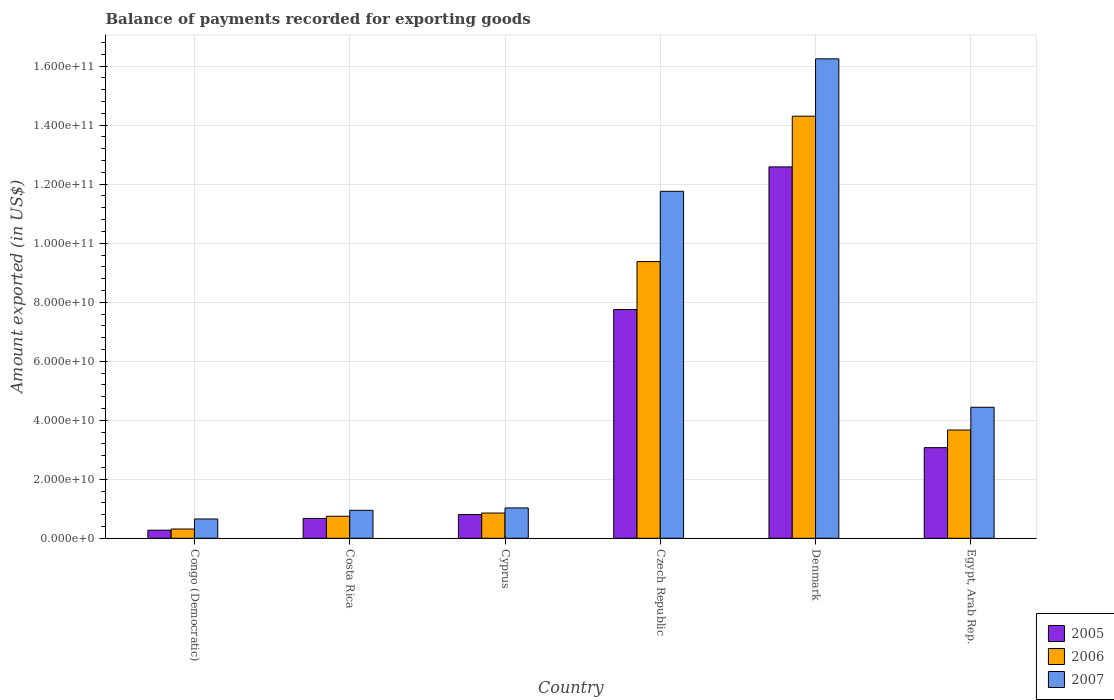How many different coloured bars are there?
Provide a short and direct response. 3. How many groups of bars are there?
Your answer should be compact. 6. Are the number of bars on each tick of the X-axis equal?
Offer a terse response. Yes. How many bars are there on the 6th tick from the left?
Ensure brevity in your answer.  3. In how many cases, is the number of bars for a given country not equal to the number of legend labels?
Your answer should be very brief. 0. What is the amount exported in 2007 in Egypt, Arab Rep.?
Provide a short and direct response. 4.44e+1. Across all countries, what is the maximum amount exported in 2005?
Your response must be concise. 1.26e+11. Across all countries, what is the minimum amount exported in 2007?
Your answer should be very brief. 6.54e+09. In which country was the amount exported in 2006 minimum?
Provide a succinct answer. Congo (Democratic). What is the total amount exported in 2005 in the graph?
Keep it short and to the point. 2.52e+11. What is the difference between the amount exported in 2007 in Denmark and that in Egypt, Arab Rep.?
Give a very brief answer. 1.18e+11. What is the difference between the amount exported in 2006 in Congo (Democratic) and the amount exported in 2007 in Costa Rica?
Offer a terse response. -6.34e+09. What is the average amount exported in 2005 per country?
Provide a succinct answer. 4.19e+1. What is the difference between the amount exported of/in 2007 and amount exported of/in 2005 in Costa Rica?
Provide a short and direct response. 2.75e+09. In how many countries, is the amount exported in 2006 greater than 136000000000 US$?
Your answer should be very brief. 1. What is the ratio of the amount exported in 2007 in Congo (Democratic) to that in Egypt, Arab Rep.?
Keep it short and to the point. 0.15. Is the difference between the amount exported in 2007 in Congo (Democratic) and Egypt, Arab Rep. greater than the difference between the amount exported in 2005 in Congo (Democratic) and Egypt, Arab Rep.?
Ensure brevity in your answer.  No. What is the difference between the highest and the second highest amount exported in 2007?
Your answer should be very brief. 4.49e+1. What is the difference between the highest and the lowest amount exported in 2006?
Your answer should be very brief. 1.40e+11. Is it the case that in every country, the sum of the amount exported in 2005 and amount exported in 2007 is greater than the amount exported in 2006?
Your answer should be very brief. Yes. How many bars are there?
Give a very brief answer. 18. Are all the bars in the graph horizontal?
Make the answer very short. No. How many countries are there in the graph?
Provide a succinct answer. 6. What is the difference between two consecutive major ticks on the Y-axis?
Offer a terse response. 2.00e+1. Are the values on the major ticks of Y-axis written in scientific E-notation?
Your response must be concise. Yes. Does the graph contain grids?
Provide a short and direct response. Yes. How many legend labels are there?
Provide a succinct answer. 3. What is the title of the graph?
Offer a terse response. Balance of payments recorded for exporting goods. What is the label or title of the Y-axis?
Offer a very short reply. Amount exported (in US$). What is the Amount exported (in US$) in 2005 in Congo (Democratic)?
Your answer should be very brief. 2.75e+09. What is the Amount exported (in US$) in 2006 in Congo (Democratic)?
Your answer should be very brief. 3.14e+09. What is the Amount exported (in US$) of 2007 in Congo (Democratic)?
Keep it short and to the point. 6.54e+09. What is the Amount exported (in US$) of 2005 in Costa Rica?
Give a very brief answer. 6.73e+09. What is the Amount exported (in US$) in 2006 in Costa Rica?
Keep it short and to the point. 7.47e+09. What is the Amount exported (in US$) of 2007 in Costa Rica?
Ensure brevity in your answer.  9.48e+09. What is the Amount exported (in US$) in 2005 in Cyprus?
Provide a succinct answer. 8.05e+09. What is the Amount exported (in US$) of 2006 in Cyprus?
Keep it short and to the point. 8.55e+09. What is the Amount exported (in US$) of 2007 in Cyprus?
Provide a short and direct response. 1.03e+1. What is the Amount exported (in US$) in 2005 in Czech Republic?
Keep it short and to the point. 7.75e+1. What is the Amount exported (in US$) in 2006 in Czech Republic?
Keep it short and to the point. 9.38e+1. What is the Amount exported (in US$) in 2007 in Czech Republic?
Your answer should be compact. 1.18e+11. What is the Amount exported (in US$) in 2005 in Denmark?
Keep it short and to the point. 1.26e+11. What is the Amount exported (in US$) in 2006 in Denmark?
Your answer should be compact. 1.43e+11. What is the Amount exported (in US$) in 2007 in Denmark?
Ensure brevity in your answer.  1.62e+11. What is the Amount exported (in US$) in 2005 in Egypt, Arab Rep.?
Provide a short and direct response. 3.07e+1. What is the Amount exported (in US$) in 2006 in Egypt, Arab Rep.?
Make the answer very short. 3.67e+1. What is the Amount exported (in US$) of 2007 in Egypt, Arab Rep.?
Offer a very short reply. 4.44e+1. Across all countries, what is the maximum Amount exported (in US$) in 2005?
Your answer should be compact. 1.26e+11. Across all countries, what is the maximum Amount exported (in US$) of 2006?
Provide a succinct answer. 1.43e+11. Across all countries, what is the maximum Amount exported (in US$) in 2007?
Offer a terse response. 1.62e+11. Across all countries, what is the minimum Amount exported (in US$) of 2005?
Give a very brief answer. 2.75e+09. Across all countries, what is the minimum Amount exported (in US$) in 2006?
Make the answer very short. 3.14e+09. Across all countries, what is the minimum Amount exported (in US$) in 2007?
Provide a short and direct response. 6.54e+09. What is the total Amount exported (in US$) in 2005 in the graph?
Your response must be concise. 2.52e+11. What is the total Amount exported (in US$) of 2006 in the graph?
Ensure brevity in your answer.  2.93e+11. What is the total Amount exported (in US$) of 2007 in the graph?
Your answer should be compact. 3.51e+11. What is the difference between the Amount exported (in US$) of 2005 in Congo (Democratic) and that in Costa Rica?
Offer a terse response. -3.98e+09. What is the difference between the Amount exported (in US$) of 2006 in Congo (Democratic) and that in Costa Rica?
Your response must be concise. -4.33e+09. What is the difference between the Amount exported (in US$) in 2007 in Congo (Democratic) and that in Costa Rica?
Keep it short and to the point. -2.94e+09. What is the difference between the Amount exported (in US$) in 2005 in Congo (Democratic) and that in Cyprus?
Provide a succinct answer. -5.30e+09. What is the difference between the Amount exported (in US$) of 2006 in Congo (Democratic) and that in Cyprus?
Offer a very short reply. -5.42e+09. What is the difference between the Amount exported (in US$) in 2007 in Congo (Democratic) and that in Cyprus?
Offer a very short reply. -3.75e+09. What is the difference between the Amount exported (in US$) of 2005 in Congo (Democratic) and that in Czech Republic?
Give a very brief answer. -7.48e+1. What is the difference between the Amount exported (in US$) in 2006 in Congo (Democratic) and that in Czech Republic?
Your answer should be very brief. -9.06e+1. What is the difference between the Amount exported (in US$) of 2007 in Congo (Democratic) and that in Czech Republic?
Offer a very short reply. -1.11e+11. What is the difference between the Amount exported (in US$) of 2005 in Congo (Democratic) and that in Denmark?
Your response must be concise. -1.23e+11. What is the difference between the Amount exported (in US$) in 2006 in Congo (Democratic) and that in Denmark?
Ensure brevity in your answer.  -1.40e+11. What is the difference between the Amount exported (in US$) in 2007 in Congo (Democratic) and that in Denmark?
Keep it short and to the point. -1.56e+11. What is the difference between the Amount exported (in US$) in 2005 in Congo (Democratic) and that in Egypt, Arab Rep.?
Your response must be concise. -2.80e+1. What is the difference between the Amount exported (in US$) in 2006 in Congo (Democratic) and that in Egypt, Arab Rep.?
Your response must be concise. -3.35e+1. What is the difference between the Amount exported (in US$) in 2007 in Congo (Democratic) and that in Egypt, Arab Rep.?
Keep it short and to the point. -3.79e+1. What is the difference between the Amount exported (in US$) in 2005 in Costa Rica and that in Cyprus?
Your answer should be very brief. -1.32e+09. What is the difference between the Amount exported (in US$) in 2006 in Costa Rica and that in Cyprus?
Ensure brevity in your answer.  -1.08e+09. What is the difference between the Amount exported (in US$) of 2007 in Costa Rica and that in Cyprus?
Offer a terse response. -8.10e+08. What is the difference between the Amount exported (in US$) in 2005 in Costa Rica and that in Czech Republic?
Your answer should be compact. -7.08e+1. What is the difference between the Amount exported (in US$) of 2006 in Costa Rica and that in Czech Republic?
Your answer should be very brief. -8.63e+1. What is the difference between the Amount exported (in US$) of 2007 in Costa Rica and that in Czech Republic?
Your answer should be compact. -1.08e+11. What is the difference between the Amount exported (in US$) in 2005 in Costa Rica and that in Denmark?
Your answer should be very brief. -1.19e+11. What is the difference between the Amount exported (in US$) in 2006 in Costa Rica and that in Denmark?
Provide a succinct answer. -1.36e+11. What is the difference between the Amount exported (in US$) in 2007 in Costa Rica and that in Denmark?
Your answer should be compact. -1.53e+11. What is the difference between the Amount exported (in US$) in 2005 in Costa Rica and that in Egypt, Arab Rep.?
Your answer should be very brief. -2.40e+1. What is the difference between the Amount exported (in US$) in 2006 in Costa Rica and that in Egypt, Arab Rep.?
Give a very brief answer. -2.92e+1. What is the difference between the Amount exported (in US$) in 2007 in Costa Rica and that in Egypt, Arab Rep.?
Provide a short and direct response. -3.49e+1. What is the difference between the Amount exported (in US$) in 2005 in Cyprus and that in Czech Republic?
Offer a very short reply. -6.95e+1. What is the difference between the Amount exported (in US$) in 2006 in Cyprus and that in Czech Republic?
Offer a very short reply. -8.52e+1. What is the difference between the Amount exported (in US$) in 2007 in Cyprus and that in Czech Republic?
Your answer should be very brief. -1.07e+11. What is the difference between the Amount exported (in US$) in 2005 in Cyprus and that in Denmark?
Your answer should be compact. -1.18e+11. What is the difference between the Amount exported (in US$) of 2006 in Cyprus and that in Denmark?
Provide a succinct answer. -1.34e+11. What is the difference between the Amount exported (in US$) of 2007 in Cyprus and that in Denmark?
Make the answer very short. -1.52e+11. What is the difference between the Amount exported (in US$) of 2005 in Cyprus and that in Egypt, Arab Rep.?
Your response must be concise. -2.27e+1. What is the difference between the Amount exported (in US$) in 2006 in Cyprus and that in Egypt, Arab Rep.?
Make the answer very short. -2.81e+1. What is the difference between the Amount exported (in US$) in 2007 in Cyprus and that in Egypt, Arab Rep.?
Your answer should be very brief. -3.41e+1. What is the difference between the Amount exported (in US$) of 2005 in Czech Republic and that in Denmark?
Your answer should be compact. -4.83e+1. What is the difference between the Amount exported (in US$) of 2006 in Czech Republic and that in Denmark?
Provide a short and direct response. -4.93e+1. What is the difference between the Amount exported (in US$) of 2007 in Czech Republic and that in Denmark?
Provide a succinct answer. -4.49e+1. What is the difference between the Amount exported (in US$) of 2005 in Czech Republic and that in Egypt, Arab Rep.?
Keep it short and to the point. 4.68e+1. What is the difference between the Amount exported (in US$) in 2006 in Czech Republic and that in Egypt, Arab Rep.?
Your answer should be very brief. 5.71e+1. What is the difference between the Amount exported (in US$) in 2007 in Czech Republic and that in Egypt, Arab Rep.?
Keep it short and to the point. 7.32e+1. What is the difference between the Amount exported (in US$) in 2005 in Denmark and that in Egypt, Arab Rep.?
Ensure brevity in your answer.  9.51e+1. What is the difference between the Amount exported (in US$) of 2006 in Denmark and that in Egypt, Arab Rep.?
Ensure brevity in your answer.  1.06e+11. What is the difference between the Amount exported (in US$) of 2007 in Denmark and that in Egypt, Arab Rep.?
Ensure brevity in your answer.  1.18e+11. What is the difference between the Amount exported (in US$) in 2005 in Congo (Democratic) and the Amount exported (in US$) in 2006 in Costa Rica?
Offer a terse response. -4.72e+09. What is the difference between the Amount exported (in US$) of 2005 in Congo (Democratic) and the Amount exported (in US$) of 2007 in Costa Rica?
Your response must be concise. -6.73e+09. What is the difference between the Amount exported (in US$) in 2006 in Congo (Democratic) and the Amount exported (in US$) in 2007 in Costa Rica?
Keep it short and to the point. -6.34e+09. What is the difference between the Amount exported (in US$) of 2005 in Congo (Democratic) and the Amount exported (in US$) of 2006 in Cyprus?
Offer a terse response. -5.81e+09. What is the difference between the Amount exported (in US$) of 2005 in Congo (Democratic) and the Amount exported (in US$) of 2007 in Cyprus?
Keep it short and to the point. -7.54e+09. What is the difference between the Amount exported (in US$) of 2006 in Congo (Democratic) and the Amount exported (in US$) of 2007 in Cyprus?
Give a very brief answer. -7.15e+09. What is the difference between the Amount exported (in US$) in 2005 in Congo (Democratic) and the Amount exported (in US$) in 2006 in Czech Republic?
Keep it short and to the point. -9.10e+1. What is the difference between the Amount exported (in US$) of 2005 in Congo (Democratic) and the Amount exported (in US$) of 2007 in Czech Republic?
Offer a very short reply. -1.15e+11. What is the difference between the Amount exported (in US$) of 2006 in Congo (Democratic) and the Amount exported (in US$) of 2007 in Czech Republic?
Keep it short and to the point. -1.14e+11. What is the difference between the Amount exported (in US$) of 2005 in Congo (Democratic) and the Amount exported (in US$) of 2006 in Denmark?
Offer a very short reply. -1.40e+11. What is the difference between the Amount exported (in US$) of 2005 in Congo (Democratic) and the Amount exported (in US$) of 2007 in Denmark?
Give a very brief answer. -1.60e+11. What is the difference between the Amount exported (in US$) in 2006 in Congo (Democratic) and the Amount exported (in US$) in 2007 in Denmark?
Give a very brief answer. -1.59e+11. What is the difference between the Amount exported (in US$) of 2005 in Congo (Democratic) and the Amount exported (in US$) of 2006 in Egypt, Arab Rep.?
Provide a succinct answer. -3.39e+1. What is the difference between the Amount exported (in US$) of 2005 in Congo (Democratic) and the Amount exported (in US$) of 2007 in Egypt, Arab Rep.?
Provide a succinct answer. -4.17e+1. What is the difference between the Amount exported (in US$) of 2006 in Congo (Democratic) and the Amount exported (in US$) of 2007 in Egypt, Arab Rep.?
Offer a terse response. -4.13e+1. What is the difference between the Amount exported (in US$) of 2005 in Costa Rica and the Amount exported (in US$) of 2006 in Cyprus?
Provide a short and direct response. -1.82e+09. What is the difference between the Amount exported (in US$) in 2005 in Costa Rica and the Amount exported (in US$) in 2007 in Cyprus?
Provide a succinct answer. -3.56e+09. What is the difference between the Amount exported (in US$) of 2006 in Costa Rica and the Amount exported (in US$) of 2007 in Cyprus?
Give a very brief answer. -2.82e+09. What is the difference between the Amount exported (in US$) in 2005 in Costa Rica and the Amount exported (in US$) in 2006 in Czech Republic?
Ensure brevity in your answer.  -8.70e+1. What is the difference between the Amount exported (in US$) of 2005 in Costa Rica and the Amount exported (in US$) of 2007 in Czech Republic?
Your response must be concise. -1.11e+11. What is the difference between the Amount exported (in US$) of 2006 in Costa Rica and the Amount exported (in US$) of 2007 in Czech Republic?
Give a very brief answer. -1.10e+11. What is the difference between the Amount exported (in US$) in 2005 in Costa Rica and the Amount exported (in US$) in 2006 in Denmark?
Your answer should be compact. -1.36e+11. What is the difference between the Amount exported (in US$) in 2005 in Costa Rica and the Amount exported (in US$) in 2007 in Denmark?
Offer a very short reply. -1.56e+11. What is the difference between the Amount exported (in US$) in 2006 in Costa Rica and the Amount exported (in US$) in 2007 in Denmark?
Your answer should be very brief. -1.55e+11. What is the difference between the Amount exported (in US$) of 2005 in Costa Rica and the Amount exported (in US$) of 2006 in Egypt, Arab Rep.?
Offer a terse response. -3.00e+1. What is the difference between the Amount exported (in US$) in 2005 in Costa Rica and the Amount exported (in US$) in 2007 in Egypt, Arab Rep.?
Provide a succinct answer. -3.77e+1. What is the difference between the Amount exported (in US$) in 2006 in Costa Rica and the Amount exported (in US$) in 2007 in Egypt, Arab Rep.?
Provide a short and direct response. -3.69e+1. What is the difference between the Amount exported (in US$) of 2005 in Cyprus and the Amount exported (in US$) of 2006 in Czech Republic?
Provide a succinct answer. -8.57e+1. What is the difference between the Amount exported (in US$) of 2005 in Cyprus and the Amount exported (in US$) of 2007 in Czech Republic?
Your answer should be very brief. -1.10e+11. What is the difference between the Amount exported (in US$) in 2006 in Cyprus and the Amount exported (in US$) in 2007 in Czech Republic?
Give a very brief answer. -1.09e+11. What is the difference between the Amount exported (in US$) of 2005 in Cyprus and the Amount exported (in US$) of 2006 in Denmark?
Offer a terse response. -1.35e+11. What is the difference between the Amount exported (in US$) of 2005 in Cyprus and the Amount exported (in US$) of 2007 in Denmark?
Give a very brief answer. -1.54e+11. What is the difference between the Amount exported (in US$) in 2006 in Cyprus and the Amount exported (in US$) in 2007 in Denmark?
Offer a very short reply. -1.54e+11. What is the difference between the Amount exported (in US$) of 2005 in Cyprus and the Amount exported (in US$) of 2006 in Egypt, Arab Rep.?
Your response must be concise. -2.86e+1. What is the difference between the Amount exported (in US$) in 2005 in Cyprus and the Amount exported (in US$) in 2007 in Egypt, Arab Rep.?
Ensure brevity in your answer.  -3.64e+1. What is the difference between the Amount exported (in US$) of 2006 in Cyprus and the Amount exported (in US$) of 2007 in Egypt, Arab Rep.?
Make the answer very short. -3.58e+1. What is the difference between the Amount exported (in US$) of 2005 in Czech Republic and the Amount exported (in US$) of 2006 in Denmark?
Ensure brevity in your answer.  -6.55e+1. What is the difference between the Amount exported (in US$) in 2005 in Czech Republic and the Amount exported (in US$) in 2007 in Denmark?
Keep it short and to the point. -8.50e+1. What is the difference between the Amount exported (in US$) of 2006 in Czech Republic and the Amount exported (in US$) of 2007 in Denmark?
Your answer should be compact. -6.87e+1. What is the difference between the Amount exported (in US$) of 2005 in Czech Republic and the Amount exported (in US$) of 2006 in Egypt, Arab Rep.?
Your response must be concise. 4.08e+1. What is the difference between the Amount exported (in US$) in 2005 in Czech Republic and the Amount exported (in US$) in 2007 in Egypt, Arab Rep.?
Give a very brief answer. 3.31e+1. What is the difference between the Amount exported (in US$) of 2006 in Czech Republic and the Amount exported (in US$) of 2007 in Egypt, Arab Rep.?
Provide a short and direct response. 4.94e+1. What is the difference between the Amount exported (in US$) in 2005 in Denmark and the Amount exported (in US$) in 2006 in Egypt, Arab Rep.?
Make the answer very short. 8.92e+1. What is the difference between the Amount exported (in US$) in 2005 in Denmark and the Amount exported (in US$) in 2007 in Egypt, Arab Rep.?
Your response must be concise. 8.15e+1. What is the difference between the Amount exported (in US$) of 2006 in Denmark and the Amount exported (in US$) of 2007 in Egypt, Arab Rep.?
Offer a very short reply. 9.86e+1. What is the average Amount exported (in US$) in 2005 per country?
Ensure brevity in your answer.  4.19e+1. What is the average Amount exported (in US$) of 2006 per country?
Provide a short and direct response. 4.88e+1. What is the average Amount exported (in US$) in 2007 per country?
Your answer should be compact. 5.85e+1. What is the difference between the Amount exported (in US$) of 2005 and Amount exported (in US$) of 2006 in Congo (Democratic)?
Make the answer very short. -3.92e+08. What is the difference between the Amount exported (in US$) in 2005 and Amount exported (in US$) in 2007 in Congo (Democratic)?
Provide a short and direct response. -3.79e+09. What is the difference between the Amount exported (in US$) of 2006 and Amount exported (in US$) of 2007 in Congo (Democratic)?
Ensure brevity in your answer.  -3.40e+09. What is the difference between the Amount exported (in US$) in 2005 and Amount exported (in US$) in 2006 in Costa Rica?
Offer a very short reply. -7.41e+08. What is the difference between the Amount exported (in US$) in 2005 and Amount exported (in US$) in 2007 in Costa Rica?
Provide a short and direct response. -2.75e+09. What is the difference between the Amount exported (in US$) of 2006 and Amount exported (in US$) of 2007 in Costa Rica?
Offer a very short reply. -2.01e+09. What is the difference between the Amount exported (in US$) of 2005 and Amount exported (in US$) of 2006 in Cyprus?
Your answer should be compact. -5.06e+08. What is the difference between the Amount exported (in US$) in 2005 and Amount exported (in US$) in 2007 in Cyprus?
Offer a very short reply. -2.24e+09. What is the difference between the Amount exported (in US$) of 2006 and Amount exported (in US$) of 2007 in Cyprus?
Give a very brief answer. -1.73e+09. What is the difference between the Amount exported (in US$) in 2005 and Amount exported (in US$) in 2006 in Czech Republic?
Provide a short and direct response. -1.62e+1. What is the difference between the Amount exported (in US$) in 2005 and Amount exported (in US$) in 2007 in Czech Republic?
Provide a succinct answer. -4.01e+1. What is the difference between the Amount exported (in US$) of 2006 and Amount exported (in US$) of 2007 in Czech Republic?
Make the answer very short. -2.38e+1. What is the difference between the Amount exported (in US$) of 2005 and Amount exported (in US$) of 2006 in Denmark?
Provide a succinct answer. -1.72e+1. What is the difference between the Amount exported (in US$) of 2005 and Amount exported (in US$) of 2007 in Denmark?
Your response must be concise. -3.66e+1. What is the difference between the Amount exported (in US$) in 2006 and Amount exported (in US$) in 2007 in Denmark?
Provide a short and direct response. -1.94e+1. What is the difference between the Amount exported (in US$) in 2005 and Amount exported (in US$) in 2006 in Egypt, Arab Rep.?
Your response must be concise. -5.96e+09. What is the difference between the Amount exported (in US$) in 2005 and Amount exported (in US$) in 2007 in Egypt, Arab Rep.?
Provide a succinct answer. -1.37e+1. What is the difference between the Amount exported (in US$) in 2006 and Amount exported (in US$) in 2007 in Egypt, Arab Rep.?
Ensure brevity in your answer.  -7.72e+09. What is the ratio of the Amount exported (in US$) in 2005 in Congo (Democratic) to that in Costa Rica?
Your answer should be very brief. 0.41. What is the ratio of the Amount exported (in US$) of 2006 in Congo (Democratic) to that in Costa Rica?
Make the answer very short. 0.42. What is the ratio of the Amount exported (in US$) in 2007 in Congo (Democratic) to that in Costa Rica?
Your response must be concise. 0.69. What is the ratio of the Amount exported (in US$) of 2005 in Congo (Democratic) to that in Cyprus?
Give a very brief answer. 0.34. What is the ratio of the Amount exported (in US$) in 2006 in Congo (Democratic) to that in Cyprus?
Keep it short and to the point. 0.37. What is the ratio of the Amount exported (in US$) in 2007 in Congo (Democratic) to that in Cyprus?
Your answer should be compact. 0.64. What is the ratio of the Amount exported (in US$) in 2005 in Congo (Democratic) to that in Czech Republic?
Provide a succinct answer. 0.04. What is the ratio of the Amount exported (in US$) of 2006 in Congo (Democratic) to that in Czech Republic?
Your answer should be very brief. 0.03. What is the ratio of the Amount exported (in US$) of 2007 in Congo (Democratic) to that in Czech Republic?
Provide a short and direct response. 0.06. What is the ratio of the Amount exported (in US$) in 2005 in Congo (Democratic) to that in Denmark?
Your answer should be very brief. 0.02. What is the ratio of the Amount exported (in US$) of 2006 in Congo (Democratic) to that in Denmark?
Provide a short and direct response. 0.02. What is the ratio of the Amount exported (in US$) of 2007 in Congo (Democratic) to that in Denmark?
Make the answer very short. 0.04. What is the ratio of the Amount exported (in US$) in 2005 in Congo (Democratic) to that in Egypt, Arab Rep.?
Keep it short and to the point. 0.09. What is the ratio of the Amount exported (in US$) of 2006 in Congo (Democratic) to that in Egypt, Arab Rep.?
Provide a short and direct response. 0.09. What is the ratio of the Amount exported (in US$) of 2007 in Congo (Democratic) to that in Egypt, Arab Rep.?
Provide a short and direct response. 0.15. What is the ratio of the Amount exported (in US$) in 2005 in Costa Rica to that in Cyprus?
Provide a short and direct response. 0.84. What is the ratio of the Amount exported (in US$) of 2006 in Costa Rica to that in Cyprus?
Ensure brevity in your answer.  0.87. What is the ratio of the Amount exported (in US$) of 2007 in Costa Rica to that in Cyprus?
Make the answer very short. 0.92. What is the ratio of the Amount exported (in US$) of 2005 in Costa Rica to that in Czech Republic?
Your answer should be very brief. 0.09. What is the ratio of the Amount exported (in US$) in 2006 in Costa Rica to that in Czech Republic?
Your response must be concise. 0.08. What is the ratio of the Amount exported (in US$) in 2007 in Costa Rica to that in Czech Republic?
Give a very brief answer. 0.08. What is the ratio of the Amount exported (in US$) of 2005 in Costa Rica to that in Denmark?
Keep it short and to the point. 0.05. What is the ratio of the Amount exported (in US$) in 2006 in Costa Rica to that in Denmark?
Ensure brevity in your answer.  0.05. What is the ratio of the Amount exported (in US$) in 2007 in Costa Rica to that in Denmark?
Provide a short and direct response. 0.06. What is the ratio of the Amount exported (in US$) in 2005 in Costa Rica to that in Egypt, Arab Rep.?
Your answer should be compact. 0.22. What is the ratio of the Amount exported (in US$) in 2006 in Costa Rica to that in Egypt, Arab Rep.?
Offer a very short reply. 0.2. What is the ratio of the Amount exported (in US$) of 2007 in Costa Rica to that in Egypt, Arab Rep.?
Provide a short and direct response. 0.21. What is the ratio of the Amount exported (in US$) in 2005 in Cyprus to that in Czech Republic?
Make the answer very short. 0.1. What is the ratio of the Amount exported (in US$) of 2006 in Cyprus to that in Czech Republic?
Give a very brief answer. 0.09. What is the ratio of the Amount exported (in US$) in 2007 in Cyprus to that in Czech Republic?
Make the answer very short. 0.09. What is the ratio of the Amount exported (in US$) of 2005 in Cyprus to that in Denmark?
Offer a terse response. 0.06. What is the ratio of the Amount exported (in US$) of 2006 in Cyprus to that in Denmark?
Your answer should be very brief. 0.06. What is the ratio of the Amount exported (in US$) of 2007 in Cyprus to that in Denmark?
Keep it short and to the point. 0.06. What is the ratio of the Amount exported (in US$) of 2005 in Cyprus to that in Egypt, Arab Rep.?
Provide a short and direct response. 0.26. What is the ratio of the Amount exported (in US$) of 2006 in Cyprus to that in Egypt, Arab Rep.?
Ensure brevity in your answer.  0.23. What is the ratio of the Amount exported (in US$) of 2007 in Cyprus to that in Egypt, Arab Rep.?
Offer a very short reply. 0.23. What is the ratio of the Amount exported (in US$) in 2005 in Czech Republic to that in Denmark?
Offer a very short reply. 0.62. What is the ratio of the Amount exported (in US$) of 2006 in Czech Republic to that in Denmark?
Offer a very short reply. 0.66. What is the ratio of the Amount exported (in US$) in 2007 in Czech Republic to that in Denmark?
Ensure brevity in your answer.  0.72. What is the ratio of the Amount exported (in US$) of 2005 in Czech Republic to that in Egypt, Arab Rep.?
Your answer should be very brief. 2.52. What is the ratio of the Amount exported (in US$) of 2006 in Czech Republic to that in Egypt, Arab Rep.?
Ensure brevity in your answer.  2.56. What is the ratio of the Amount exported (in US$) of 2007 in Czech Republic to that in Egypt, Arab Rep.?
Give a very brief answer. 2.65. What is the ratio of the Amount exported (in US$) of 2005 in Denmark to that in Egypt, Arab Rep.?
Make the answer very short. 4.1. What is the ratio of the Amount exported (in US$) in 2006 in Denmark to that in Egypt, Arab Rep.?
Your answer should be compact. 3.9. What is the ratio of the Amount exported (in US$) in 2007 in Denmark to that in Egypt, Arab Rep.?
Your answer should be very brief. 3.66. What is the difference between the highest and the second highest Amount exported (in US$) of 2005?
Provide a short and direct response. 4.83e+1. What is the difference between the highest and the second highest Amount exported (in US$) in 2006?
Offer a terse response. 4.93e+1. What is the difference between the highest and the second highest Amount exported (in US$) in 2007?
Provide a succinct answer. 4.49e+1. What is the difference between the highest and the lowest Amount exported (in US$) of 2005?
Keep it short and to the point. 1.23e+11. What is the difference between the highest and the lowest Amount exported (in US$) of 2006?
Keep it short and to the point. 1.40e+11. What is the difference between the highest and the lowest Amount exported (in US$) of 2007?
Offer a terse response. 1.56e+11. 